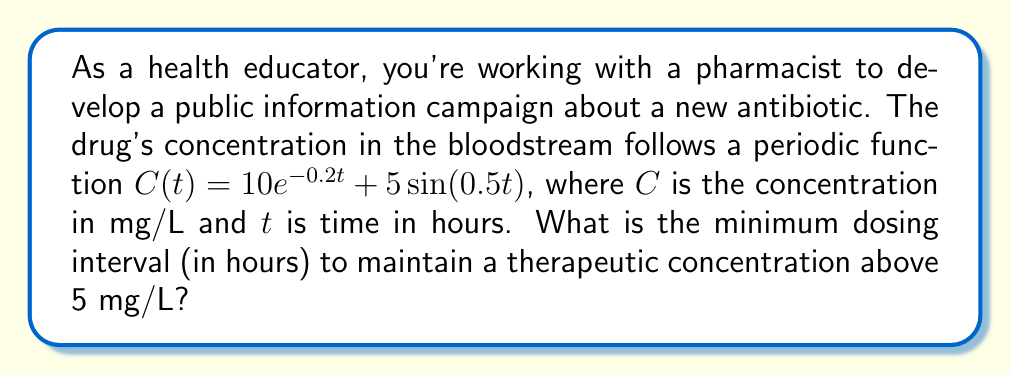Can you answer this question? To solve this problem, we need to follow these steps:

1) The drug concentration is given by $C(t) = 10e^{-0.2t} + 5\sin(0.5t)$

2) We need to find when this concentration drops below 5 mg/L. This occurs when:

   $10e^{-0.2t} + 5\sin(0.5t) = 5$

3) This equation is complex and doesn't have a simple analytical solution. We need to solve it numerically or graphically.

4) Using a graphing calculator or software, we can plot $C(t)$ and $y = 5$ on the same graph.

5) The first intersection point after $t = 0$ occurs at approximately $t = 11.3$ hours.

6) This means the concentration drops below 5 mg/L after about 11.3 hours.

7) Therefore, to maintain a therapeutic concentration above 5 mg/L, the drug should be administered at intervals shorter than 11.3 hours.

8) Rounding down to the nearest hour for safety, the dosing interval should be 11 hours.
Answer: 11 hours 